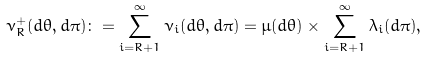<formula> <loc_0><loc_0><loc_500><loc_500>\nu _ { R } ^ { + } ( d \theta , d \pi ) \colon = \sum _ { i = R + 1 } ^ { \infty } \nu _ { i } ( d \theta , d \pi ) = \mu ( d \theta ) \times \sum _ { i = R + 1 } ^ { \infty } \lambda _ { i } ( d \pi ) ,</formula> 